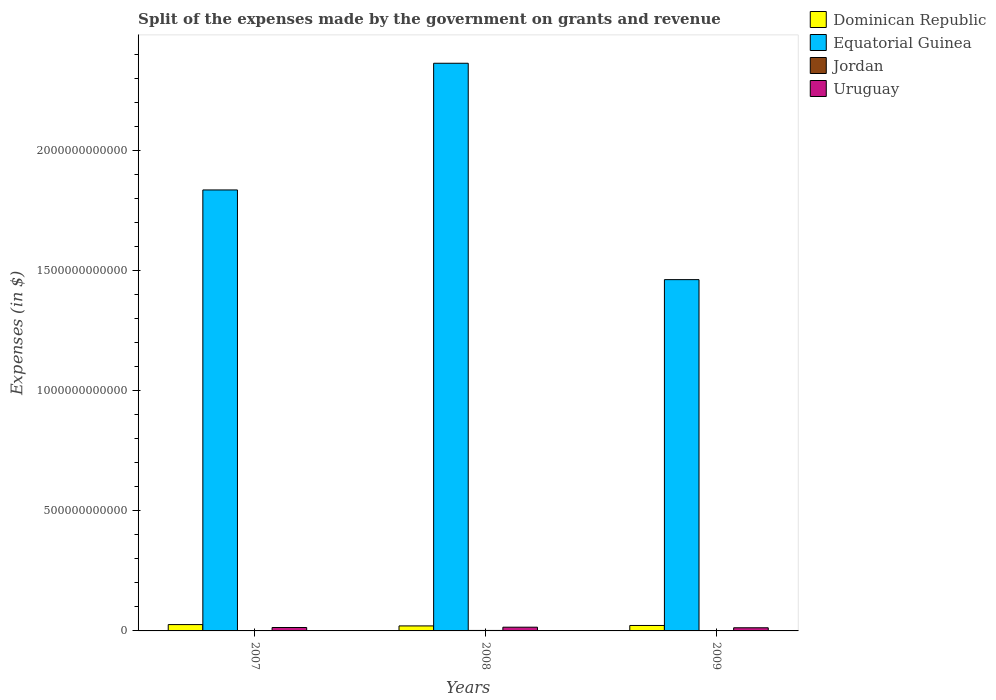How many groups of bars are there?
Give a very brief answer. 3. Are the number of bars on each tick of the X-axis equal?
Provide a short and direct response. Yes. How many bars are there on the 1st tick from the left?
Provide a short and direct response. 4. What is the label of the 2nd group of bars from the left?
Keep it short and to the point. 2008. What is the expenses made by the government on grants and revenue in Jordan in 2009?
Keep it short and to the point. 1.62e+09. Across all years, what is the maximum expenses made by the government on grants and revenue in Dominican Republic?
Provide a short and direct response. 2.64e+1. Across all years, what is the minimum expenses made by the government on grants and revenue in Dominican Republic?
Offer a very short reply. 2.09e+1. What is the total expenses made by the government on grants and revenue in Equatorial Guinea in the graph?
Offer a terse response. 5.66e+12. What is the difference between the expenses made by the government on grants and revenue in Uruguay in 2007 and that in 2009?
Your answer should be compact. 1.12e+09. What is the difference between the expenses made by the government on grants and revenue in Uruguay in 2008 and the expenses made by the government on grants and revenue in Equatorial Guinea in 2009?
Your answer should be very brief. -1.45e+12. What is the average expenses made by the government on grants and revenue in Equatorial Guinea per year?
Offer a terse response. 1.89e+12. In the year 2009, what is the difference between the expenses made by the government on grants and revenue in Dominican Republic and expenses made by the government on grants and revenue in Uruguay?
Give a very brief answer. 9.56e+09. What is the ratio of the expenses made by the government on grants and revenue in Uruguay in 2008 to that in 2009?
Your response must be concise. 1.18. What is the difference between the highest and the second highest expenses made by the government on grants and revenue in Uruguay?
Provide a short and direct response. 1.28e+09. What is the difference between the highest and the lowest expenses made by the government on grants and revenue in Dominican Republic?
Offer a very short reply. 5.50e+09. In how many years, is the expenses made by the government on grants and revenue in Equatorial Guinea greater than the average expenses made by the government on grants and revenue in Equatorial Guinea taken over all years?
Provide a succinct answer. 1. Is the sum of the expenses made by the government on grants and revenue in Dominican Republic in 2007 and 2008 greater than the maximum expenses made by the government on grants and revenue in Uruguay across all years?
Offer a terse response. Yes. What does the 2nd bar from the left in 2008 represents?
Keep it short and to the point. Equatorial Guinea. What does the 1st bar from the right in 2009 represents?
Your answer should be very brief. Uruguay. Is it the case that in every year, the sum of the expenses made by the government on grants and revenue in Dominican Republic and expenses made by the government on grants and revenue in Jordan is greater than the expenses made by the government on grants and revenue in Equatorial Guinea?
Your answer should be very brief. No. What is the difference between two consecutive major ticks on the Y-axis?
Your answer should be compact. 5.00e+11. Are the values on the major ticks of Y-axis written in scientific E-notation?
Your response must be concise. No. Does the graph contain any zero values?
Ensure brevity in your answer.  No. Does the graph contain grids?
Give a very brief answer. No. Where does the legend appear in the graph?
Your response must be concise. Top right. How many legend labels are there?
Provide a short and direct response. 4. How are the legend labels stacked?
Ensure brevity in your answer.  Vertical. What is the title of the graph?
Give a very brief answer. Split of the expenses made by the government on grants and revenue. What is the label or title of the X-axis?
Give a very brief answer. Years. What is the label or title of the Y-axis?
Keep it short and to the point. Expenses (in $). What is the Expenses (in $) in Dominican Republic in 2007?
Offer a terse response. 2.64e+1. What is the Expenses (in $) of Equatorial Guinea in 2007?
Provide a succinct answer. 1.84e+12. What is the Expenses (in $) of Jordan in 2007?
Offer a terse response. 9.58e+08. What is the Expenses (in $) of Uruguay in 2007?
Keep it short and to the point. 1.42e+1. What is the Expenses (in $) in Dominican Republic in 2008?
Provide a succinct answer. 2.09e+1. What is the Expenses (in $) in Equatorial Guinea in 2008?
Offer a very short reply. 2.36e+12. What is the Expenses (in $) of Jordan in 2008?
Ensure brevity in your answer.  1.96e+09. What is the Expenses (in $) of Uruguay in 2008?
Provide a short and direct response. 1.55e+1. What is the Expenses (in $) of Dominican Republic in 2009?
Make the answer very short. 2.26e+1. What is the Expenses (in $) of Equatorial Guinea in 2009?
Your answer should be compact. 1.46e+12. What is the Expenses (in $) in Jordan in 2009?
Make the answer very short. 1.62e+09. What is the Expenses (in $) in Uruguay in 2009?
Your answer should be compact. 1.31e+1. Across all years, what is the maximum Expenses (in $) of Dominican Republic?
Your response must be concise. 2.64e+1. Across all years, what is the maximum Expenses (in $) of Equatorial Guinea?
Provide a succinct answer. 2.36e+12. Across all years, what is the maximum Expenses (in $) in Jordan?
Provide a succinct answer. 1.96e+09. Across all years, what is the maximum Expenses (in $) in Uruguay?
Make the answer very short. 1.55e+1. Across all years, what is the minimum Expenses (in $) of Dominican Republic?
Your answer should be very brief. 2.09e+1. Across all years, what is the minimum Expenses (in $) in Equatorial Guinea?
Make the answer very short. 1.46e+12. Across all years, what is the minimum Expenses (in $) in Jordan?
Offer a terse response. 9.58e+08. Across all years, what is the minimum Expenses (in $) of Uruguay?
Your answer should be compact. 1.31e+1. What is the total Expenses (in $) of Dominican Republic in the graph?
Make the answer very short. 6.99e+1. What is the total Expenses (in $) of Equatorial Guinea in the graph?
Provide a short and direct response. 5.66e+12. What is the total Expenses (in $) in Jordan in the graph?
Give a very brief answer. 4.54e+09. What is the total Expenses (in $) in Uruguay in the graph?
Your answer should be compact. 4.28e+1. What is the difference between the Expenses (in $) of Dominican Republic in 2007 and that in 2008?
Your answer should be compact. 5.50e+09. What is the difference between the Expenses (in $) in Equatorial Guinea in 2007 and that in 2008?
Provide a short and direct response. -5.27e+11. What is the difference between the Expenses (in $) of Jordan in 2007 and that in 2008?
Provide a short and direct response. -1.00e+09. What is the difference between the Expenses (in $) of Uruguay in 2007 and that in 2008?
Your answer should be very brief. -1.28e+09. What is the difference between the Expenses (in $) of Dominican Republic in 2007 and that in 2009?
Offer a very short reply. 3.70e+09. What is the difference between the Expenses (in $) in Equatorial Guinea in 2007 and that in 2009?
Keep it short and to the point. 3.73e+11. What is the difference between the Expenses (in $) of Jordan in 2007 and that in 2009?
Provide a succinct answer. -6.63e+08. What is the difference between the Expenses (in $) in Uruguay in 2007 and that in 2009?
Your answer should be very brief. 1.12e+09. What is the difference between the Expenses (in $) of Dominican Republic in 2008 and that in 2009?
Provide a short and direct response. -1.80e+09. What is the difference between the Expenses (in $) in Equatorial Guinea in 2008 and that in 2009?
Ensure brevity in your answer.  9.01e+11. What is the difference between the Expenses (in $) in Jordan in 2008 and that in 2009?
Your answer should be compact. 3.38e+08. What is the difference between the Expenses (in $) of Uruguay in 2008 and that in 2009?
Ensure brevity in your answer.  2.41e+09. What is the difference between the Expenses (in $) in Dominican Republic in 2007 and the Expenses (in $) in Equatorial Guinea in 2008?
Make the answer very short. -2.34e+12. What is the difference between the Expenses (in $) in Dominican Republic in 2007 and the Expenses (in $) in Jordan in 2008?
Your answer should be compact. 2.44e+1. What is the difference between the Expenses (in $) in Dominican Republic in 2007 and the Expenses (in $) in Uruguay in 2008?
Your answer should be compact. 1.09e+1. What is the difference between the Expenses (in $) in Equatorial Guinea in 2007 and the Expenses (in $) in Jordan in 2008?
Your answer should be compact. 1.83e+12. What is the difference between the Expenses (in $) in Equatorial Guinea in 2007 and the Expenses (in $) in Uruguay in 2008?
Your answer should be very brief. 1.82e+12. What is the difference between the Expenses (in $) of Jordan in 2007 and the Expenses (in $) of Uruguay in 2008?
Offer a very short reply. -1.45e+1. What is the difference between the Expenses (in $) in Dominican Republic in 2007 and the Expenses (in $) in Equatorial Guinea in 2009?
Your answer should be very brief. -1.44e+12. What is the difference between the Expenses (in $) of Dominican Republic in 2007 and the Expenses (in $) of Jordan in 2009?
Keep it short and to the point. 2.47e+1. What is the difference between the Expenses (in $) of Dominican Republic in 2007 and the Expenses (in $) of Uruguay in 2009?
Provide a succinct answer. 1.33e+1. What is the difference between the Expenses (in $) of Equatorial Guinea in 2007 and the Expenses (in $) of Jordan in 2009?
Make the answer very short. 1.83e+12. What is the difference between the Expenses (in $) in Equatorial Guinea in 2007 and the Expenses (in $) in Uruguay in 2009?
Ensure brevity in your answer.  1.82e+12. What is the difference between the Expenses (in $) in Jordan in 2007 and the Expenses (in $) in Uruguay in 2009?
Offer a terse response. -1.21e+1. What is the difference between the Expenses (in $) of Dominican Republic in 2008 and the Expenses (in $) of Equatorial Guinea in 2009?
Give a very brief answer. -1.44e+12. What is the difference between the Expenses (in $) of Dominican Republic in 2008 and the Expenses (in $) of Jordan in 2009?
Offer a terse response. 1.92e+1. What is the difference between the Expenses (in $) of Dominican Republic in 2008 and the Expenses (in $) of Uruguay in 2009?
Give a very brief answer. 7.76e+09. What is the difference between the Expenses (in $) of Equatorial Guinea in 2008 and the Expenses (in $) of Jordan in 2009?
Keep it short and to the point. 2.36e+12. What is the difference between the Expenses (in $) in Equatorial Guinea in 2008 and the Expenses (in $) in Uruguay in 2009?
Give a very brief answer. 2.35e+12. What is the difference between the Expenses (in $) of Jordan in 2008 and the Expenses (in $) of Uruguay in 2009?
Ensure brevity in your answer.  -1.11e+1. What is the average Expenses (in $) of Dominican Republic per year?
Give a very brief answer. 2.33e+1. What is the average Expenses (in $) of Equatorial Guinea per year?
Offer a very short reply. 1.89e+12. What is the average Expenses (in $) in Jordan per year?
Give a very brief answer. 1.51e+09. What is the average Expenses (in $) in Uruguay per year?
Provide a short and direct response. 1.43e+1. In the year 2007, what is the difference between the Expenses (in $) in Dominican Republic and Expenses (in $) in Equatorial Guinea?
Make the answer very short. -1.81e+12. In the year 2007, what is the difference between the Expenses (in $) of Dominican Republic and Expenses (in $) of Jordan?
Keep it short and to the point. 2.54e+1. In the year 2007, what is the difference between the Expenses (in $) of Dominican Republic and Expenses (in $) of Uruguay?
Make the answer very short. 1.21e+1. In the year 2007, what is the difference between the Expenses (in $) of Equatorial Guinea and Expenses (in $) of Jordan?
Keep it short and to the point. 1.83e+12. In the year 2007, what is the difference between the Expenses (in $) in Equatorial Guinea and Expenses (in $) in Uruguay?
Provide a short and direct response. 1.82e+12. In the year 2007, what is the difference between the Expenses (in $) in Jordan and Expenses (in $) in Uruguay?
Provide a succinct answer. -1.33e+1. In the year 2008, what is the difference between the Expenses (in $) of Dominican Republic and Expenses (in $) of Equatorial Guinea?
Give a very brief answer. -2.34e+12. In the year 2008, what is the difference between the Expenses (in $) in Dominican Republic and Expenses (in $) in Jordan?
Your answer should be very brief. 1.89e+1. In the year 2008, what is the difference between the Expenses (in $) of Dominican Republic and Expenses (in $) of Uruguay?
Provide a succinct answer. 5.35e+09. In the year 2008, what is the difference between the Expenses (in $) of Equatorial Guinea and Expenses (in $) of Jordan?
Offer a terse response. 2.36e+12. In the year 2008, what is the difference between the Expenses (in $) in Equatorial Guinea and Expenses (in $) in Uruguay?
Your answer should be compact. 2.35e+12. In the year 2008, what is the difference between the Expenses (in $) in Jordan and Expenses (in $) in Uruguay?
Provide a succinct answer. -1.35e+1. In the year 2009, what is the difference between the Expenses (in $) of Dominican Republic and Expenses (in $) of Equatorial Guinea?
Keep it short and to the point. -1.44e+12. In the year 2009, what is the difference between the Expenses (in $) of Dominican Republic and Expenses (in $) of Jordan?
Offer a very short reply. 2.10e+1. In the year 2009, what is the difference between the Expenses (in $) in Dominican Republic and Expenses (in $) in Uruguay?
Offer a very short reply. 9.56e+09. In the year 2009, what is the difference between the Expenses (in $) in Equatorial Guinea and Expenses (in $) in Jordan?
Offer a terse response. 1.46e+12. In the year 2009, what is the difference between the Expenses (in $) of Equatorial Guinea and Expenses (in $) of Uruguay?
Make the answer very short. 1.45e+12. In the year 2009, what is the difference between the Expenses (in $) in Jordan and Expenses (in $) in Uruguay?
Your response must be concise. -1.15e+1. What is the ratio of the Expenses (in $) of Dominican Republic in 2007 to that in 2008?
Offer a terse response. 1.26. What is the ratio of the Expenses (in $) of Equatorial Guinea in 2007 to that in 2008?
Keep it short and to the point. 0.78. What is the ratio of the Expenses (in $) in Jordan in 2007 to that in 2008?
Your response must be concise. 0.49. What is the ratio of the Expenses (in $) of Uruguay in 2007 to that in 2008?
Give a very brief answer. 0.92. What is the ratio of the Expenses (in $) in Dominican Republic in 2007 to that in 2009?
Provide a succinct answer. 1.16. What is the ratio of the Expenses (in $) of Equatorial Guinea in 2007 to that in 2009?
Offer a terse response. 1.26. What is the ratio of the Expenses (in $) in Jordan in 2007 to that in 2009?
Offer a terse response. 0.59. What is the ratio of the Expenses (in $) of Uruguay in 2007 to that in 2009?
Your answer should be very brief. 1.09. What is the ratio of the Expenses (in $) in Dominican Republic in 2008 to that in 2009?
Offer a terse response. 0.92. What is the ratio of the Expenses (in $) in Equatorial Guinea in 2008 to that in 2009?
Provide a short and direct response. 1.62. What is the ratio of the Expenses (in $) in Jordan in 2008 to that in 2009?
Provide a succinct answer. 1.21. What is the ratio of the Expenses (in $) of Uruguay in 2008 to that in 2009?
Your answer should be compact. 1.18. What is the difference between the highest and the second highest Expenses (in $) in Dominican Republic?
Offer a very short reply. 3.70e+09. What is the difference between the highest and the second highest Expenses (in $) of Equatorial Guinea?
Your response must be concise. 5.27e+11. What is the difference between the highest and the second highest Expenses (in $) in Jordan?
Provide a short and direct response. 3.38e+08. What is the difference between the highest and the second highest Expenses (in $) in Uruguay?
Your response must be concise. 1.28e+09. What is the difference between the highest and the lowest Expenses (in $) in Dominican Republic?
Ensure brevity in your answer.  5.50e+09. What is the difference between the highest and the lowest Expenses (in $) of Equatorial Guinea?
Your response must be concise. 9.01e+11. What is the difference between the highest and the lowest Expenses (in $) of Jordan?
Your answer should be very brief. 1.00e+09. What is the difference between the highest and the lowest Expenses (in $) of Uruguay?
Your answer should be very brief. 2.41e+09. 